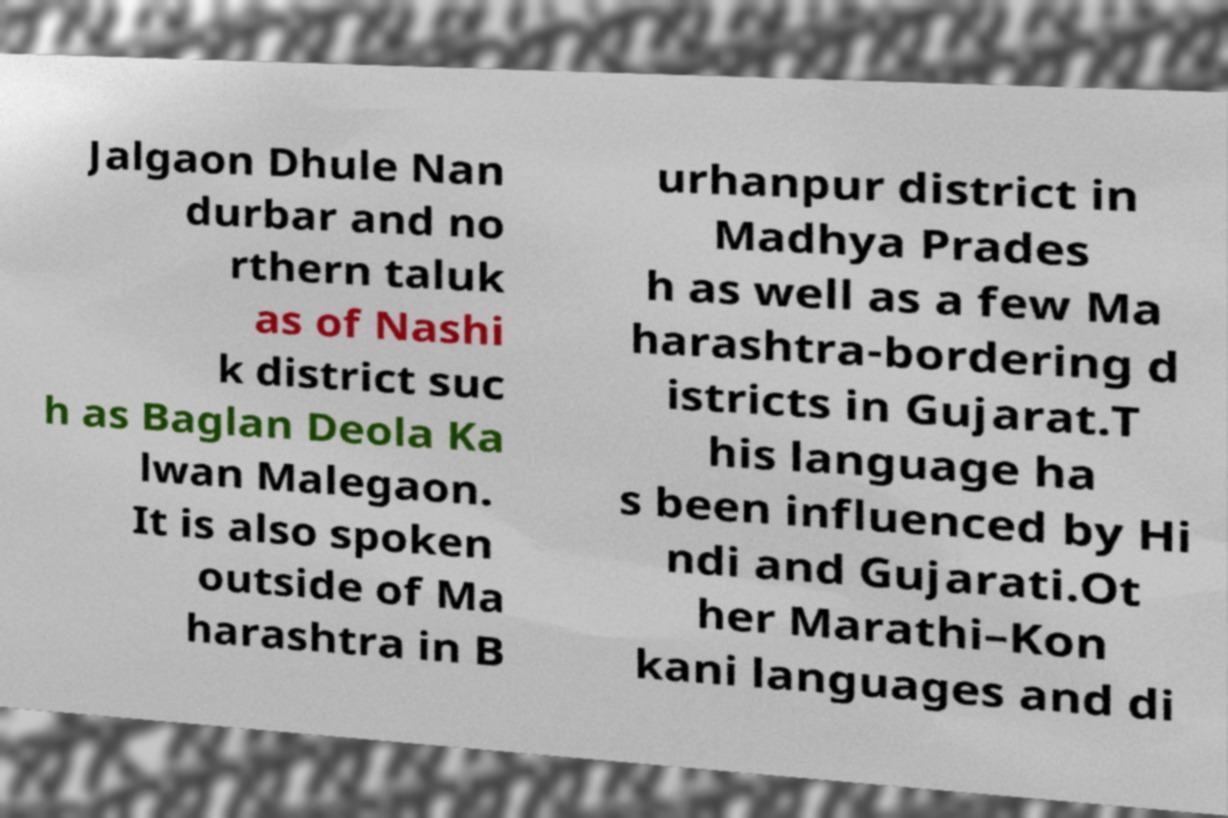I need the written content from this picture converted into text. Can you do that? Jalgaon Dhule Nan durbar and no rthern taluk as of Nashi k district suc h as Baglan Deola Ka lwan Malegaon. It is also spoken outside of Ma harashtra in B urhanpur district in Madhya Prades h as well as a few Ma harashtra-bordering d istricts in Gujarat.T his language ha s been influenced by Hi ndi and Gujarati.Ot her Marathi–Kon kani languages and di 